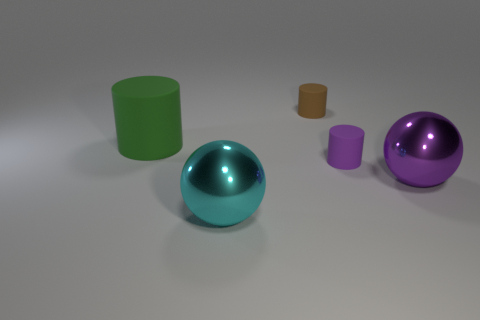How many things are brown rubber objects that are behind the big green matte thing or big things that are left of the purple shiny object?
Provide a short and direct response. 3. What number of other things are there of the same color as the large rubber cylinder?
Make the answer very short. 0. Are there more large spheres that are in front of the purple metal sphere than brown matte objects on the right side of the purple rubber object?
Offer a very short reply. Yes. Is there any other thing that has the same size as the purple matte cylinder?
Offer a very short reply. Yes. What number of blocks are either large cyan shiny things or tiny green things?
Offer a terse response. 0. What number of objects are either green rubber cylinders behind the cyan metal thing or purple metal things?
Give a very brief answer. 2. The shiny object that is on the right side of the large sphere that is to the left of the cylinder that is to the right of the brown matte thing is what shape?
Offer a very short reply. Sphere. How many large purple things are the same shape as the cyan shiny thing?
Your answer should be compact. 1. Is the tiny brown object made of the same material as the cyan ball?
Offer a very short reply. No. What number of things are right of the big object that is behind the ball on the right side of the small brown matte cylinder?
Your answer should be compact. 4. 